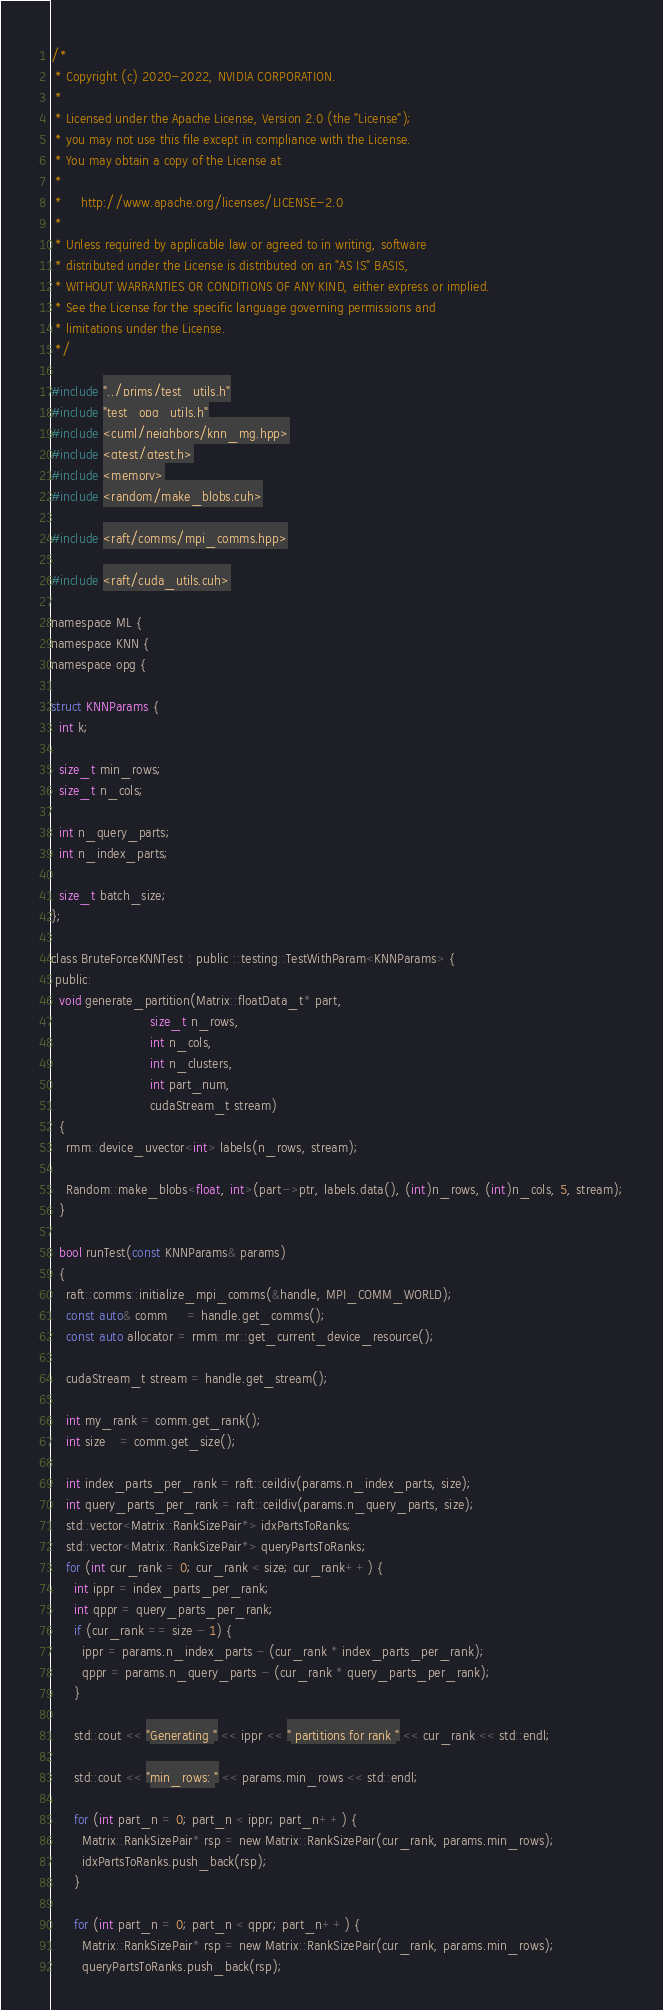Convert code to text. <code><loc_0><loc_0><loc_500><loc_500><_Cuda_>/*
 * Copyright (c) 2020-2022, NVIDIA CORPORATION.
 *
 * Licensed under the Apache License, Version 2.0 (the "License");
 * you may not use this file except in compliance with the License.
 * You may obtain a copy of the License at
 *
 *     http://www.apache.org/licenses/LICENSE-2.0
 *
 * Unless required by applicable law or agreed to in writing, software
 * distributed under the License is distributed on an "AS IS" BASIS,
 * WITHOUT WARRANTIES OR CONDITIONS OF ANY KIND, either express or implied.
 * See the License for the specific language governing permissions and
 * limitations under the License.
 */

#include "../prims/test_utils.h"
#include "test_opg_utils.h"
#include <cuml/neighbors/knn_mg.hpp>
#include <gtest/gtest.h>
#include <memory>
#include <random/make_blobs.cuh>

#include <raft/comms/mpi_comms.hpp>

#include <raft/cuda_utils.cuh>

namespace ML {
namespace KNN {
namespace opg {

struct KNNParams {
  int k;

  size_t min_rows;
  size_t n_cols;

  int n_query_parts;
  int n_index_parts;

  size_t batch_size;
};

class BruteForceKNNTest : public ::testing::TestWithParam<KNNParams> {
 public:
  void generate_partition(Matrix::floatData_t* part,
                          size_t n_rows,
                          int n_cols,
                          int n_clusters,
                          int part_num,
                          cudaStream_t stream)
  {
    rmm::device_uvector<int> labels(n_rows, stream);

    Random::make_blobs<float, int>(part->ptr, labels.data(), (int)n_rows, (int)n_cols, 5, stream);
  }

  bool runTest(const KNNParams& params)
  {
    raft::comms::initialize_mpi_comms(&handle, MPI_COMM_WORLD);
    const auto& comm     = handle.get_comms();
    const auto allocator = rmm::mr::get_current_device_resource();

    cudaStream_t stream = handle.get_stream();

    int my_rank = comm.get_rank();
    int size    = comm.get_size();

    int index_parts_per_rank = raft::ceildiv(params.n_index_parts, size);
    int query_parts_per_rank = raft::ceildiv(params.n_query_parts, size);
    std::vector<Matrix::RankSizePair*> idxPartsToRanks;
    std::vector<Matrix::RankSizePair*> queryPartsToRanks;
    for (int cur_rank = 0; cur_rank < size; cur_rank++) {
      int ippr = index_parts_per_rank;
      int qppr = query_parts_per_rank;
      if (cur_rank == size - 1) {
        ippr = params.n_index_parts - (cur_rank * index_parts_per_rank);
        qppr = params.n_query_parts - (cur_rank * query_parts_per_rank);
      }

      std::cout << "Generating " << ippr << " partitions for rank " << cur_rank << std::endl;

      std::cout << "min_rows: " << params.min_rows << std::endl;

      for (int part_n = 0; part_n < ippr; part_n++) {
        Matrix::RankSizePair* rsp = new Matrix::RankSizePair(cur_rank, params.min_rows);
        idxPartsToRanks.push_back(rsp);
      }

      for (int part_n = 0; part_n < qppr; part_n++) {
        Matrix::RankSizePair* rsp = new Matrix::RankSizePair(cur_rank, params.min_rows);
        queryPartsToRanks.push_back(rsp);</code> 